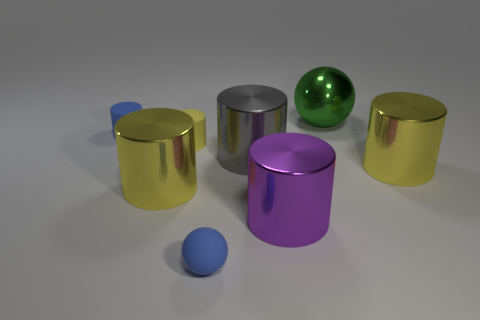Is the number of small yellow rubber things that are in front of the matte ball the same as the number of metal cylinders that are in front of the gray object?
Keep it short and to the point. No. There is a blue matte thing behind the purple object; does it have the same size as the sphere that is behind the small blue cylinder?
Offer a terse response. No. The small matte thing in front of the purple cylinder left of the large thing on the right side of the big green metallic ball is what shape?
Keep it short and to the point. Sphere. What size is the gray shiny object that is the same shape as the purple thing?
Your response must be concise. Large. What color is the object that is to the right of the yellow matte cylinder and on the left side of the large gray shiny cylinder?
Ensure brevity in your answer.  Blue. Is the large purple cylinder made of the same material as the blue object in front of the blue cylinder?
Provide a succinct answer. No. Are there fewer large yellow cylinders that are to the right of the large green thing than tiny matte cylinders?
Ensure brevity in your answer.  Yes. What number of other objects are the same shape as the green metal thing?
Your answer should be very brief. 1. Is there anything else that is the same color as the tiny matte sphere?
Offer a terse response. Yes. Does the small matte sphere have the same color as the small matte object that is behind the small yellow thing?
Make the answer very short. Yes. 